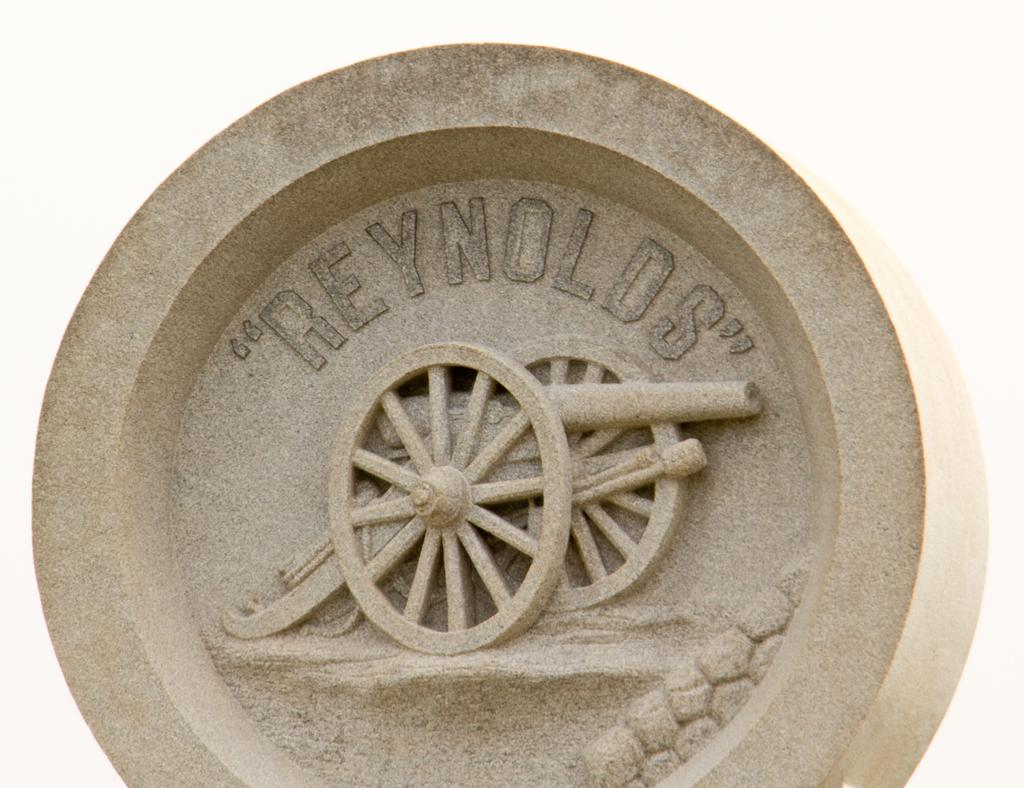What is the main shape of the object in the picture? The main shape of the object in the picture is round. What can be seen on the surface of the round object? The round object has something written on it. What is the color of the background in the image? The background of the image is white in color. What hobbies does the round object enjoy in the image? There is no information about the hobbies of the round object in the image. 